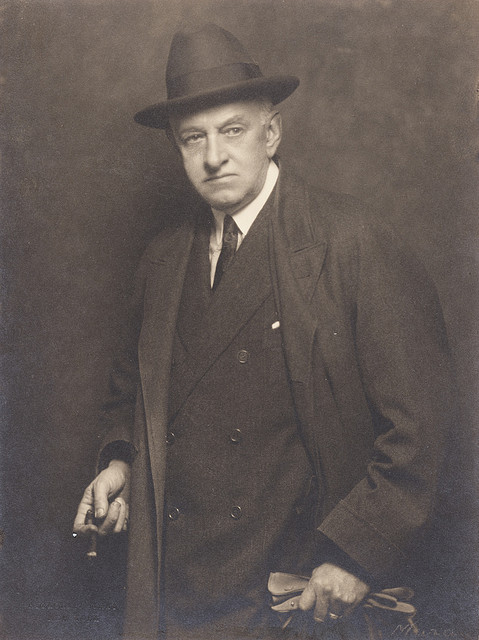<image>What kind of glasses is he wearing? The person is not wearing any glasses. What kind of glasses is he wearing? He is not wearing any glasses. 